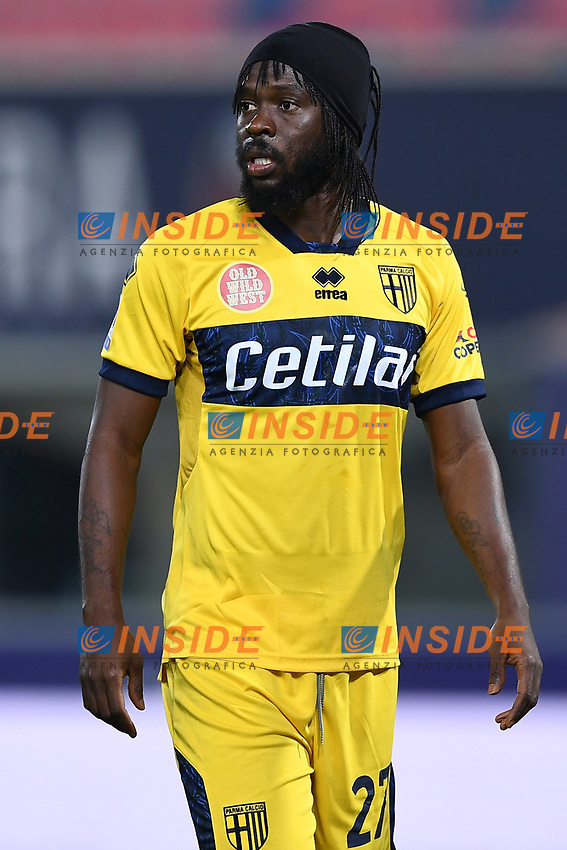What might the colors and emblem on the athlete's jersey suggest about the geographical location or origin of his team? The vibrant blue and yellow hues of the jersey, adorned with the emblem of ‘Cetilà’, likely hint at its Italian origins, as these colors are seen in various sports uniforms from teams across Italy. The emblem, positioned over the heart and depicting a shield with a prominent castle design, is reflective of many historic symbols associated with Italian cities' coats of arms. Such details not only suggest a professional and well-sponsored team but also subtly nod to its cultural heritage, possibly linking back to Parma, a city known for its deep historic and cultural roots in Italy. 